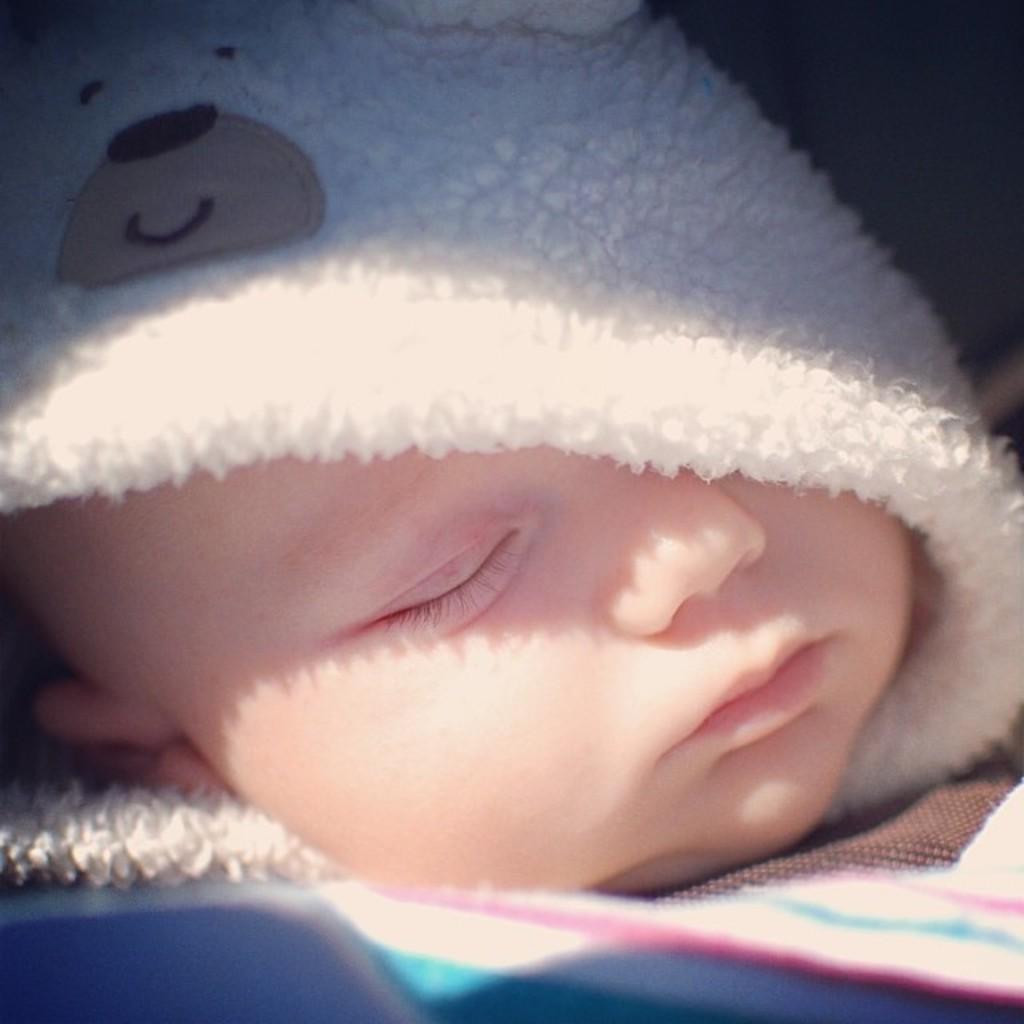Could you give a brief overview of what you see in this image? In this image we can see a kid who is wearing sweater sleeping and there is teddy bear picture on it. 